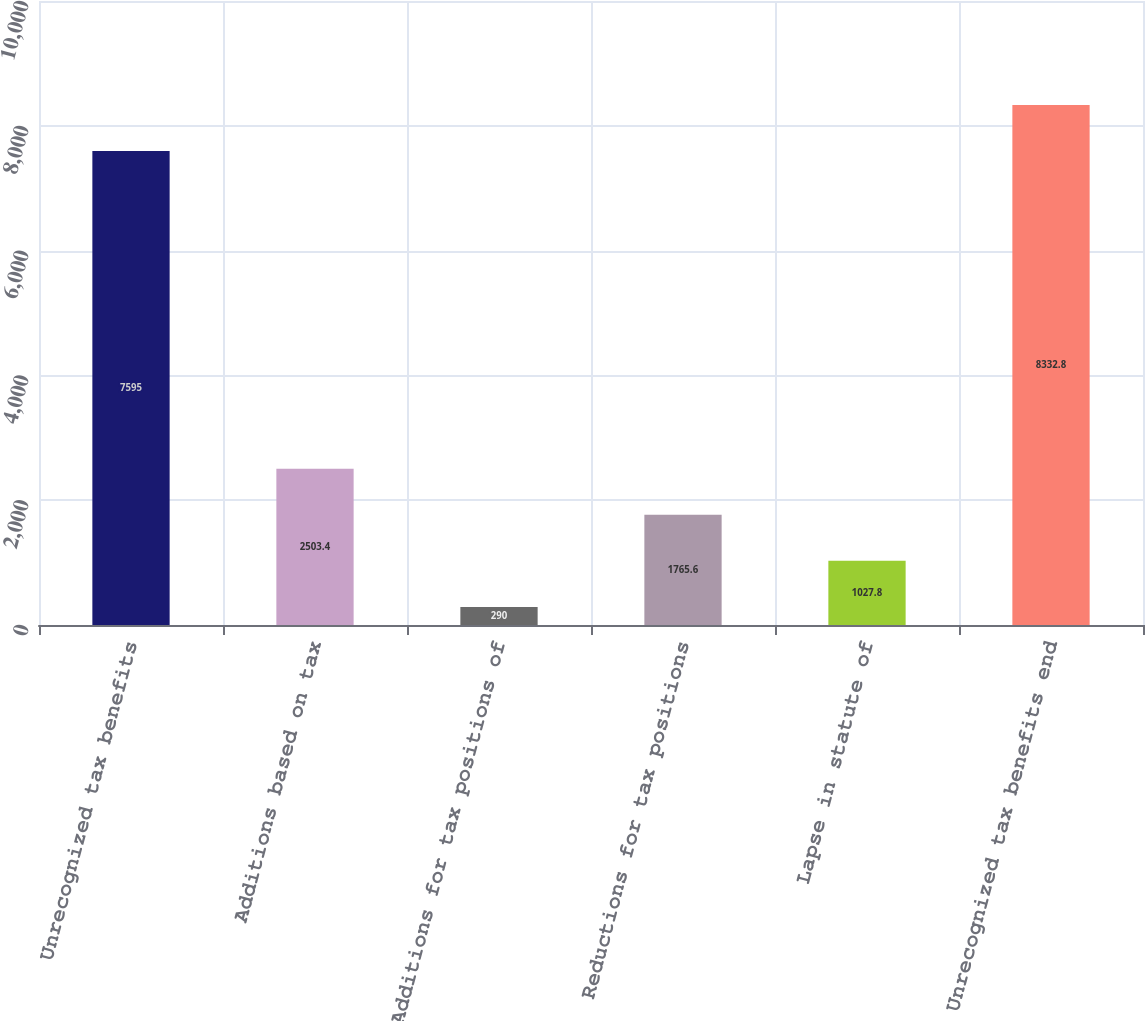Convert chart. <chart><loc_0><loc_0><loc_500><loc_500><bar_chart><fcel>Unrecognized tax benefits<fcel>Additions based on tax<fcel>Additions for tax positions of<fcel>Reductions for tax positions<fcel>Lapse in statute of<fcel>Unrecognized tax benefits end<nl><fcel>7595<fcel>2503.4<fcel>290<fcel>1765.6<fcel>1027.8<fcel>8332.8<nl></chart> 